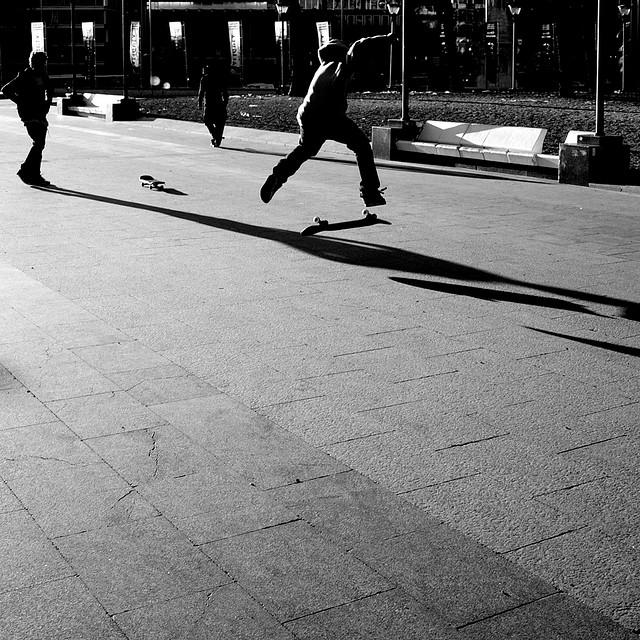On what kind of paving is the boy riding?
Keep it brief. Concrete. What is the person wearing?
Short answer required. Clothes. How many blocks of white paint are there on the ground?
Short answer required. 0. What is the boy doing?
Concise answer only. Skateboarding. How many benches are there?
Keep it brief. 2. How many people are in this picture?
Keep it brief. 3. What are these kids doing?
Concise answer only. Skateboarding. Why is are the people on the skateboard in danger?
Be succinct. No. How many skateboard wheels are on the ground?
Answer briefly. 0. What time of day is it based on the length of the shadows?
Quick response, please. Evening. What color is the rug?
Keep it brief. No rug. 